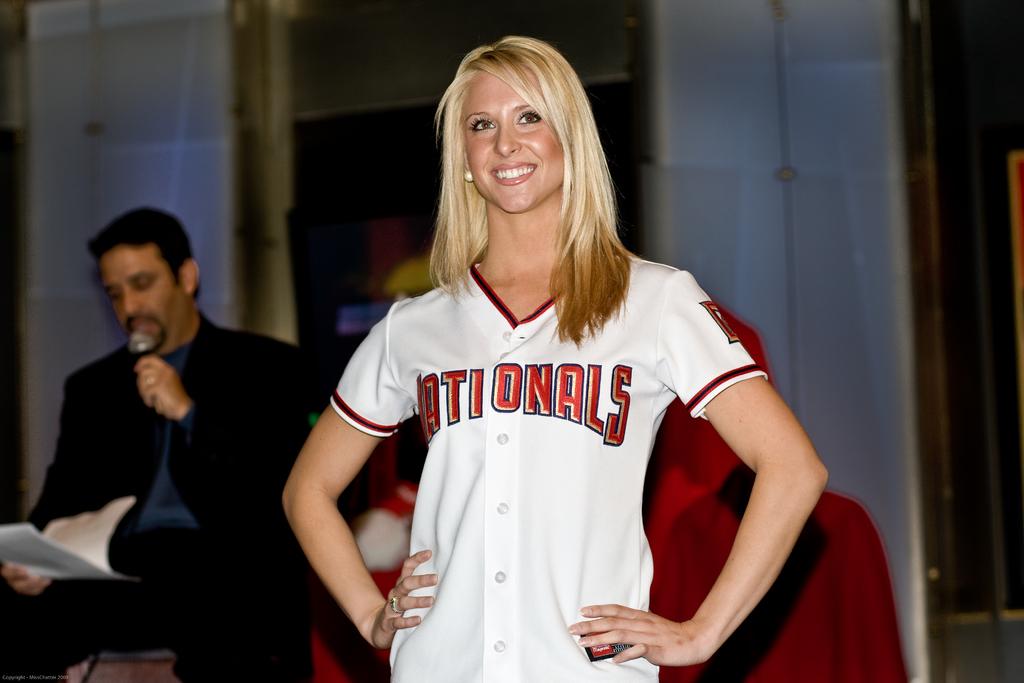What is said on the woman's t-shirt?
Offer a terse response. Nationals. 